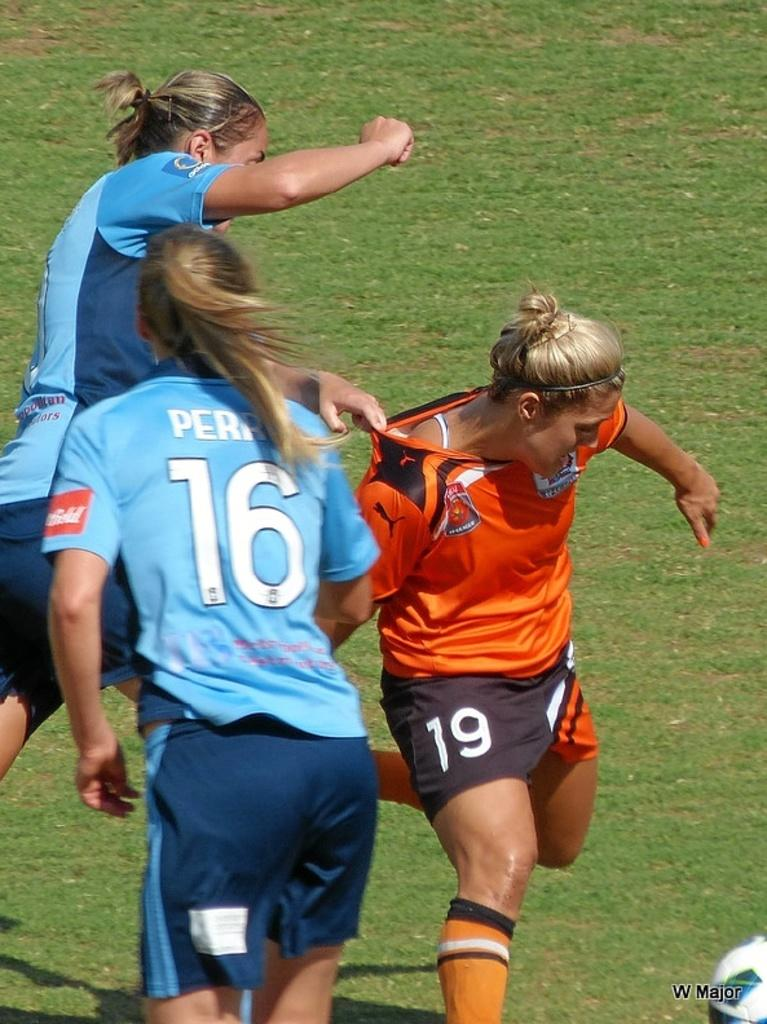<image>
Describe the image concisely. Several soccer players, including jersey numbers 16 and 19, play on the field. 